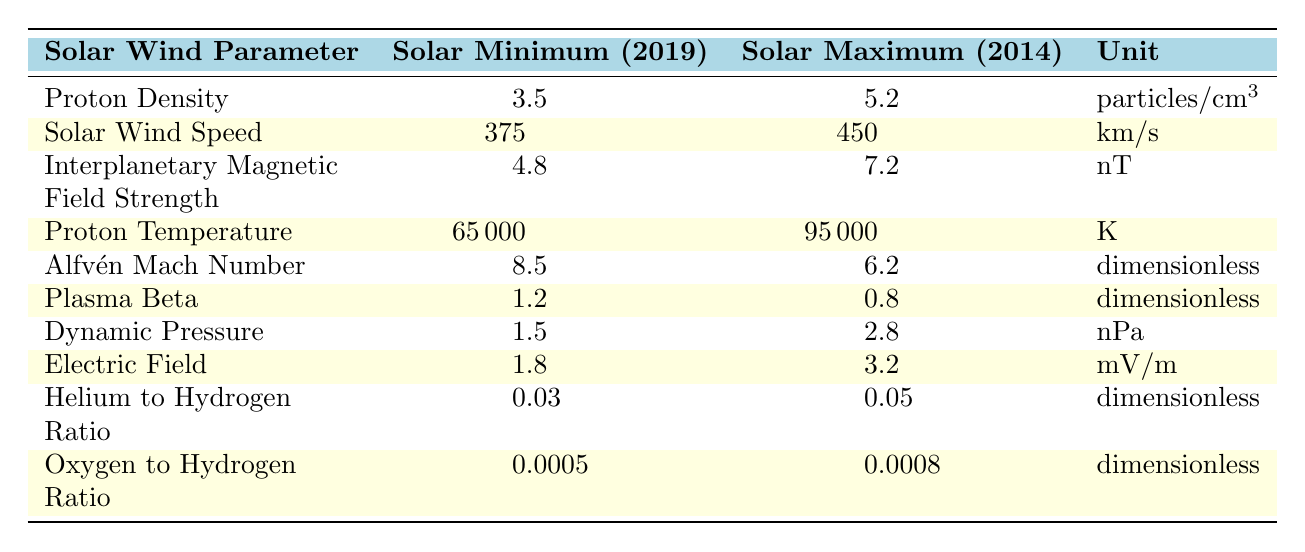What is the proton density during solar maximum in 2014? According to the table, the proton density during solar maximum in 2014 is specifically listed as 5.2 particles/cm³.
Answer: 5.2 particles/cm³ What was the solar wind speed during solar minimum in 2019? The table shows that the solar wind speed during solar minimum in 2019 is recorded as 375 km/s.
Answer: 375 km/s What is the difference in interplanetary magnetic field strength between solar maximum and solar minimum? The interplanetary magnetic field strength at solar maximum is 7.2 nT and at solar minimum it is 4.8 nT. The difference is 7.2 - 4.8 = 2.4 nT.
Answer: 2.4 nT Which solar wind parameter shows an increase from solar minimum to maximum? Proton density, solar wind speed, interplanetary magnetic field strength, and proton temperature all show increases when comparing 2019 (solar minimum) to 2014 (solar maximum).
Answer: Proton density, solar wind speed, interplanetary magnetic field strength, proton temperature What is the average dynamic pressure during solar minimum and maximum? The dynamic pressure during solar minimum is 1.5 nPa and during solar maximum it is 2.8 nPa. The average is (1.5 + 2.8) / 2 = 2.15 nPa.
Answer: 2.15 nPa Is the Alfvén Mach number higher during solar minimum or maximum? The Alfvén Mach number is 8.5 during solar minimum and 6.2 during solar maximum, indicating that it is higher during solar minimum.
Answer: Higher during solar minimum What can you conclude about the proton temperature in relation to solar activity? The proton temperature is higher during solar maximum (95000 K) compared to solar minimum (65000 K), suggesting increased thermal energy and solar activity.
Answer: Higher during solar maximum If the solar wind speed is averaged between solar minimum and maximum, what is the result? The solar wind speed during solar minimum is 375 km/s and during maximum is 450 km/s. The average is (375 + 450) / 2 = 412.5 km/s.
Answer: 412.5 km/s Is the electric field stronger during solar maximum than solar minimum? Yes, the electric field is 3.2 mV/m during solar maximum and 1.8 mV/m during solar minimum, indicating it is stronger in maximum.
Answer: Yes What is the trend in Helium to Hydrogen ratio from solar minimum to maximum? The ratio increases from 0.03 during solar minimum to 0.05 during solar maximum, indicating a rising trend.
Answer: Increases Which solar wind parameter has the greatest absolute change from minimum to maximum? The change in proton temperature is the greatest, increasing from 65000 K to 95000 K, which is a change of 30000 K.
Answer: Proton temperature 